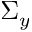<formula> <loc_0><loc_0><loc_500><loc_500>\Sigma _ { y }</formula> 